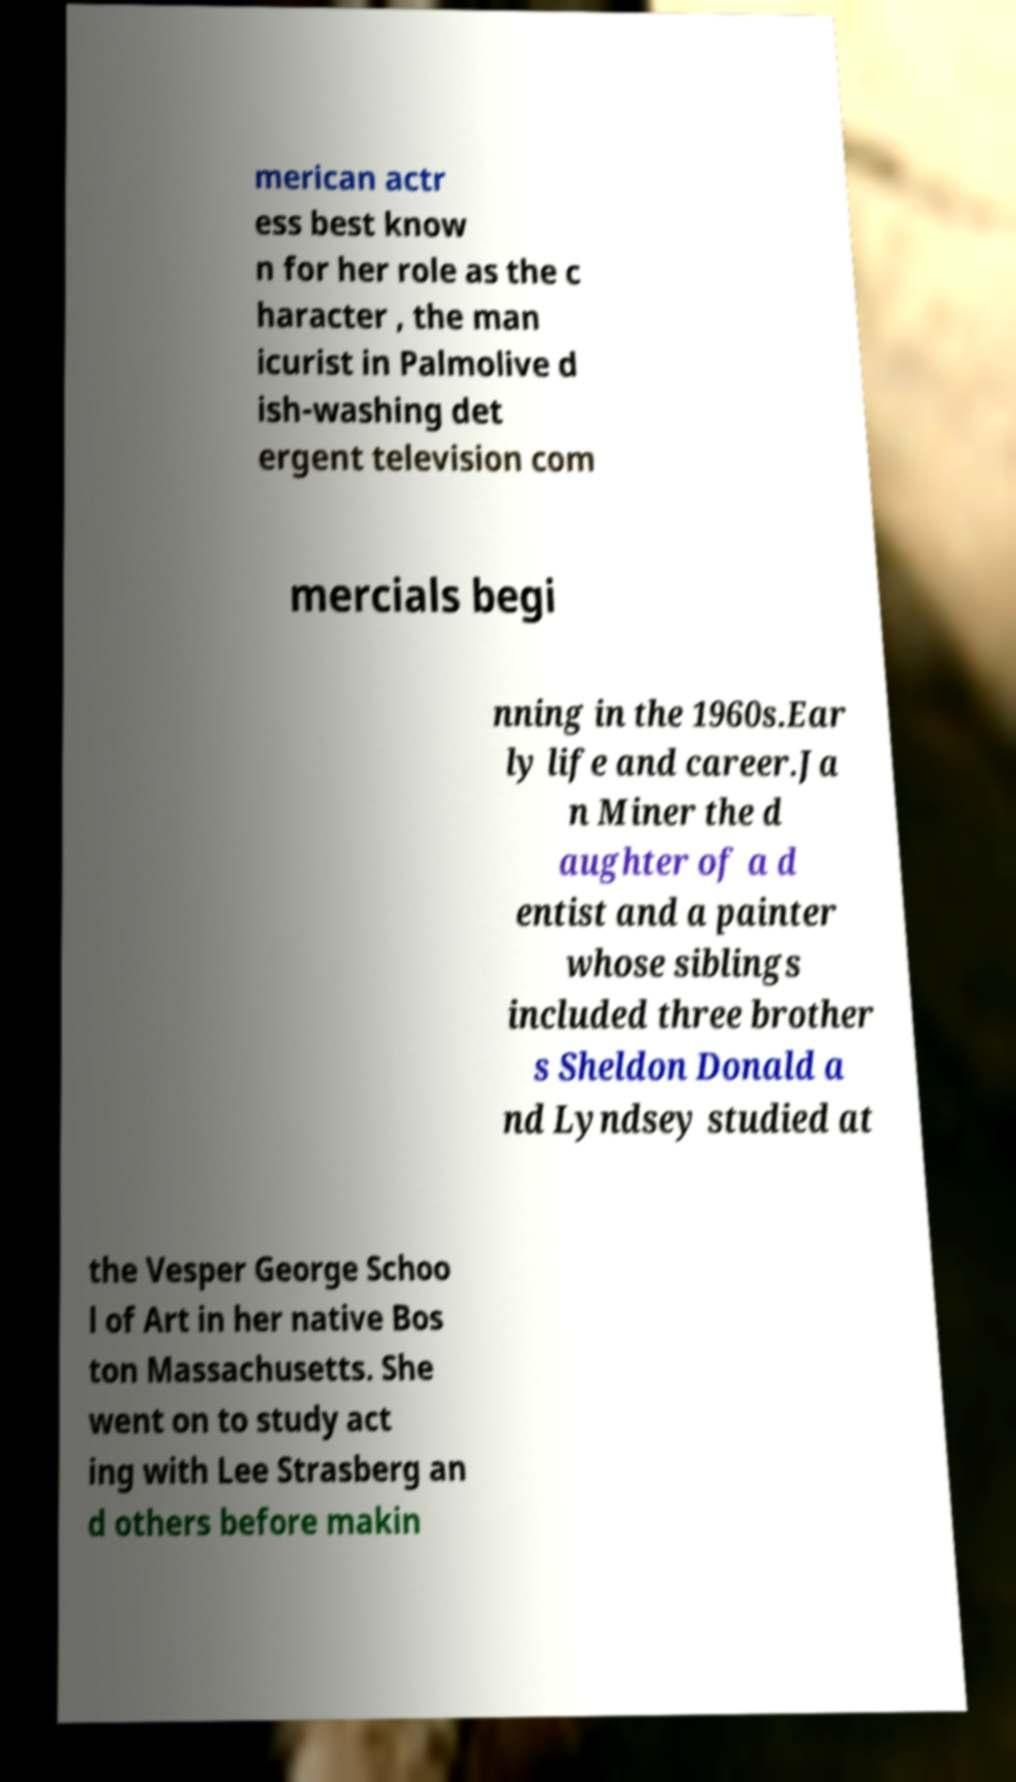Could you assist in decoding the text presented in this image and type it out clearly? merican actr ess best know n for her role as the c haracter , the man icurist in Palmolive d ish-washing det ergent television com mercials begi nning in the 1960s.Ear ly life and career.Ja n Miner the d aughter of a d entist and a painter whose siblings included three brother s Sheldon Donald a nd Lyndsey studied at the Vesper George Schoo l of Art in her native Bos ton Massachusetts. She went on to study act ing with Lee Strasberg an d others before makin 